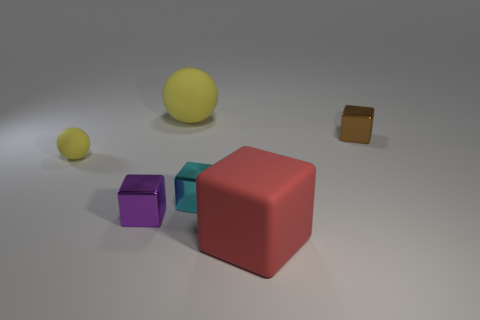What size is the matte thing that is both on the right side of the purple cube and in front of the tiny brown thing?
Give a very brief answer. Large. There is a yellow object that is on the right side of the purple object; does it have the same size as the brown metal thing?
Ensure brevity in your answer.  No. There is a big ball; does it have the same color as the object on the left side of the purple thing?
Offer a terse response. Yes. The big cube that is made of the same material as the small yellow sphere is what color?
Provide a succinct answer. Red. Is the small ball made of the same material as the big object right of the large yellow ball?
Offer a very short reply. Yes. How many things are small brown metal cubes or small shiny blocks?
Your answer should be very brief. 3. What material is the ball that is the same color as the small rubber object?
Give a very brief answer. Rubber. Is there a tiny yellow rubber object of the same shape as the red matte object?
Provide a succinct answer. No. There is a tiny purple metal object; what number of spheres are to the right of it?
Give a very brief answer. 1. There is a yellow object that is in front of the shiny object that is to the right of the red matte cube; what is it made of?
Your response must be concise. Rubber. 